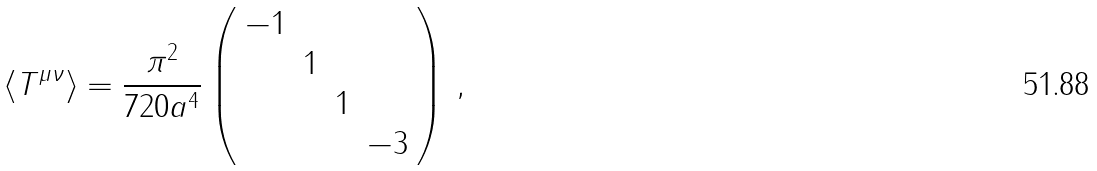<formula> <loc_0><loc_0><loc_500><loc_500>\langle T ^ { \mu \nu } \rangle = \frac { \pi ^ { 2 } } { 7 2 0 a ^ { 4 } } \left ( \begin{array} { c c c c } - 1 & & & \\ & 1 & & \\ & & 1 & \\ & & & - 3 \end{array} \right ) \, ,</formula> 